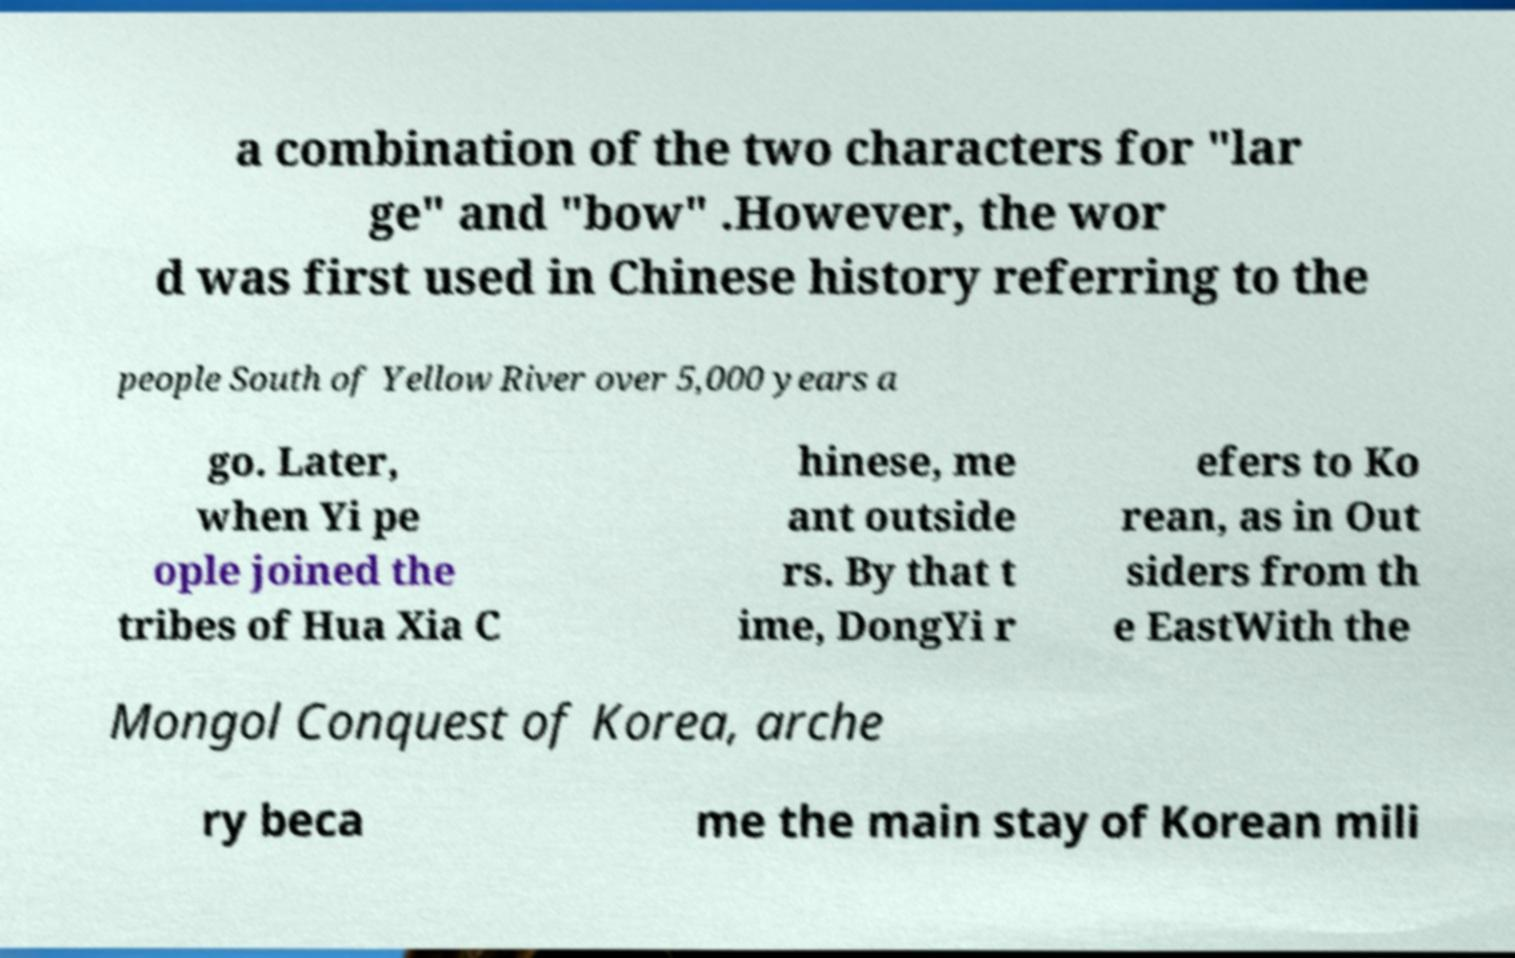Please read and relay the text visible in this image. What does it say? a combination of the two characters for "lar ge" and "bow" .However, the wor d was first used in Chinese history referring to the people South of Yellow River over 5,000 years a go. Later, when Yi pe ople joined the tribes of Hua Xia C hinese, me ant outside rs. By that t ime, DongYi r efers to Ko rean, as in Out siders from th e EastWith the Mongol Conquest of Korea, arche ry beca me the main stay of Korean mili 